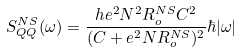<formula> <loc_0><loc_0><loc_500><loc_500>S _ { Q Q } ^ { N S } ( \omega ) = \frac { h e ^ { 2 } N ^ { 2 } R _ { o } ^ { N S } C ^ { 2 } } { ( C + e ^ { 2 } N R _ { o } ^ { N S } ) ^ { 2 } } \hbar { | } \omega |</formula> 